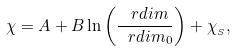<formula> <loc_0><loc_0><loc_500><loc_500>\chi = A + B \ln \left ( \frac { \ r d i m } { \ r d i m _ { 0 } } \right ) + \chi _ { _ { S } } ,</formula> 